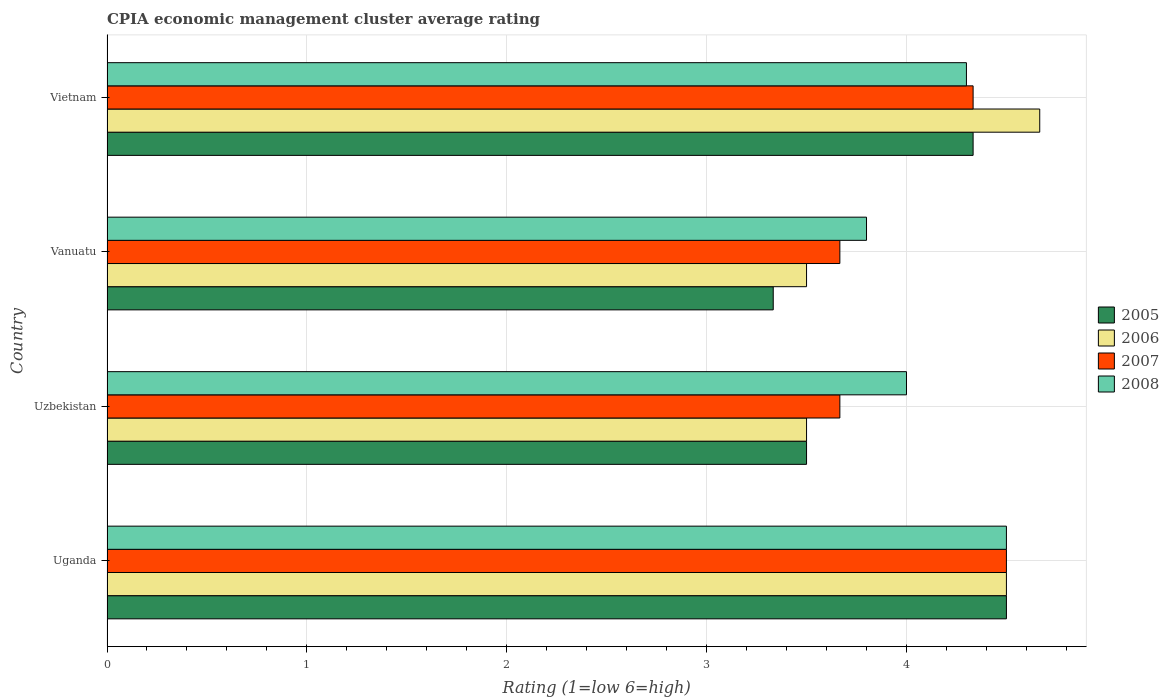How many different coloured bars are there?
Your answer should be very brief. 4. Are the number of bars on each tick of the Y-axis equal?
Provide a succinct answer. Yes. What is the label of the 3rd group of bars from the top?
Your response must be concise. Uzbekistan. Across all countries, what is the minimum CPIA rating in 2007?
Provide a short and direct response. 3.67. In which country was the CPIA rating in 2006 maximum?
Offer a very short reply. Vietnam. In which country was the CPIA rating in 2005 minimum?
Your answer should be very brief. Vanuatu. What is the total CPIA rating in 2008 in the graph?
Make the answer very short. 16.6. What is the difference between the CPIA rating in 2008 in Uzbekistan and that in Vanuatu?
Provide a short and direct response. 0.2. What is the difference between the CPIA rating in 2006 in Uzbekistan and the CPIA rating in 2008 in Vietnam?
Offer a very short reply. -0.8. What is the average CPIA rating in 2005 per country?
Offer a terse response. 3.92. What is the difference between the CPIA rating in 2008 and CPIA rating in 2006 in Uganda?
Offer a very short reply. 0. In how many countries, is the CPIA rating in 2008 greater than 3.6 ?
Provide a short and direct response. 4. What is the ratio of the CPIA rating in 2006 in Uganda to that in Vanuatu?
Offer a terse response. 1.29. Is the CPIA rating in 2007 in Uganda less than that in Uzbekistan?
Provide a succinct answer. No. What is the difference between the highest and the second highest CPIA rating in 2007?
Ensure brevity in your answer.  0.17. What is the difference between the highest and the lowest CPIA rating in 2007?
Give a very brief answer. 0.83. In how many countries, is the CPIA rating in 2006 greater than the average CPIA rating in 2006 taken over all countries?
Provide a succinct answer. 2. What does the 2nd bar from the bottom in Uzbekistan represents?
Offer a very short reply. 2006. How many bars are there?
Your answer should be compact. 16. How many countries are there in the graph?
Provide a short and direct response. 4. What is the difference between two consecutive major ticks on the X-axis?
Give a very brief answer. 1. Does the graph contain grids?
Ensure brevity in your answer.  Yes. How many legend labels are there?
Make the answer very short. 4. What is the title of the graph?
Make the answer very short. CPIA economic management cluster average rating. Does "2013" appear as one of the legend labels in the graph?
Make the answer very short. No. What is the label or title of the X-axis?
Make the answer very short. Rating (1=low 6=high). What is the Rating (1=low 6=high) in 2007 in Uzbekistan?
Provide a succinct answer. 3.67. What is the Rating (1=low 6=high) in 2005 in Vanuatu?
Provide a short and direct response. 3.33. What is the Rating (1=low 6=high) in 2006 in Vanuatu?
Your response must be concise. 3.5. What is the Rating (1=low 6=high) in 2007 in Vanuatu?
Your answer should be very brief. 3.67. What is the Rating (1=low 6=high) of 2008 in Vanuatu?
Provide a short and direct response. 3.8. What is the Rating (1=low 6=high) of 2005 in Vietnam?
Your answer should be compact. 4.33. What is the Rating (1=low 6=high) in 2006 in Vietnam?
Your answer should be very brief. 4.67. What is the Rating (1=low 6=high) of 2007 in Vietnam?
Offer a very short reply. 4.33. What is the Rating (1=low 6=high) in 2008 in Vietnam?
Offer a terse response. 4.3. Across all countries, what is the maximum Rating (1=low 6=high) of 2005?
Give a very brief answer. 4.5. Across all countries, what is the maximum Rating (1=low 6=high) in 2006?
Your response must be concise. 4.67. Across all countries, what is the maximum Rating (1=low 6=high) in 2007?
Provide a succinct answer. 4.5. Across all countries, what is the minimum Rating (1=low 6=high) of 2005?
Keep it short and to the point. 3.33. Across all countries, what is the minimum Rating (1=low 6=high) of 2006?
Offer a terse response. 3.5. Across all countries, what is the minimum Rating (1=low 6=high) of 2007?
Offer a very short reply. 3.67. What is the total Rating (1=low 6=high) of 2005 in the graph?
Make the answer very short. 15.67. What is the total Rating (1=low 6=high) in 2006 in the graph?
Provide a short and direct response. 16.17. What is the total Rating (1=low 6=high) in 2007 in the graph?
Your answer should be very brief. 16.17. What is the difference between the Rating (1=low 6=high) of 2007 in Uganda and that in Uzbekistan?
Keep it short and to the point. 0.83. What is the difference between the Rating (1=low 6=high) of 2005 in Uganda and that in Vanuatu?
Make the answer very short. 1.17. What is the difference between the Rating (1=low 6=high) in 2006 in Uganda and that in Vanuatu?
Your answer should be compact. 1. What is the difference between the Rating (1=low 6=high) of 2008 in Uganda and that in Vanuatu?
Ensure brevity in your answer.  0.7. What is the difference between the Rating (1=low 6=high) in 2005 in Uganda and that in Vietnam?
Offer a terse response. 0.17. What is the difference between the Rating (1=low 6=high) in 2006 in Uganda and that in Vietnam?
Provide a succinct answer. -0.17. What is the difference between the Rating (1=low 6=high) of 2007 in Uzbekistan and that in Vanuatu?
Your answer should be very brief. 0. What is the difference between the Rating (1=low 6=high) of 2005 in Uzbekistan and that in Vietnam?
Offer a very short reply. -0.83. What is the difference between the Rating (1=low 6=high) in 2006 in Uzbekistan and that in Vietnam?
Your answer should be very brief. -1.17. What is the difference between the Rating (1=low 6=high) in 2007 in Uzbekistan and that in Vietnam?
Offer a terse response. -0.67. What is the difference between the Rating (1=low 6=high) in 2006 in Vanuatu and that in Vietnam?
Provide a short and direct response. -1.17. What is the difference between the Rating (1=low 6=high) in 2005 in Uganda and the Rating (1=low 6=high) in 2006 in Uzbekistan?
Make the answer very short. 1. What is the difference between the Rating (1=low 6=high) of 2005 in Uganda and the Rating (1=low 6=high) of 2007 in Uzbekistan?
Make the answer very short. 0.83. What is the difference between the Rating (1=low 6=high) in 2006 in Uganda and the Rating (1=low 6=high) in 2007 in Uzbekistan?
Give a very brief answer. 0.83. What is the difference between the Rating (1=low 6=high) in 2007 in Uganda and the Rating (1=low 6=high) in 2008 in Uzbekistan?
Provide a succinct answer. 0.5. What is the difference between the Rating (1=low 6=high) of 2005 in Uganda and the Rating (1=low 6=high) of 2007 in Vanuatu?
Your answer should be compact. 0.83. What is the difference between the Rating (1=low 6=high) of 2006 in Uganda and the Rating (1=low 6=high) of 2008 in Vanuatu?
Give a very brief answer. 0.7. What is the difference between the Rating (1=low 6=high) in 2007 in Uganda and the Rating (1=low 6=high) in 2008 in Vanuatu?
Offer a terse response. 0.7. What is the difference between the Rating (1=low 6=high) of 2005 in Uganda and the Rating (1=low 6=high) of 2006 in Vietnam?
Ensure brevity in your answer.  -0.17. What is the difference between the Rating (1=low 6=high) of 2005 in Uganda and the Rating (1=low 6=high) of 2007 in Vietnam?
Your response must be concise. 0.17. What is the difference between the Rating (1=low 6=high) of 2006 in Uganda and the Rating (1=low 6=high) of 2007 in Vietnam?
Your response must be concise. 0.17. What is the difference between the Rating (1=low 6=high) of 2006 in Uganda and the Rating (1=low 6=high) of 2008 in Vietnam?
Provide a short and direct response. 0.2. What is the difference between the Rating (1=low 6=high) in 2005 in Uzbekistan and the Rating (1=low 6=high) in 2006 in Vanuatu?
Your answer should be very brief. 0. What is the difference between the Rating (1=low 6=high) in 2005 in Uzbekistan and the Rating (1=low 6=high) in 2007 in Vanuatu?
Your answer should be very brief. -0.17. What is the difference between the Rating (1=low 6=high) of 2006 in Uzbekistan and the Rating (1=low 6=high) of 2007 in Vanuatu?
Provide a succinct answer. -0.17. What is the difference between the Rating (1=low 6=high) of 2007 in Uzbekistan and the Rating (1=low 6=high) of 2008 in Vanuatu?
Your answer should be very brief. -0.13. What is the difference between the Rating (1=low 6=high) in 2005 in Uzbekistan and the Rating (1=low 6=high) in 2006 in Vietnam?
Provide a short and direct response. -1.17. What is the difference between the Rating (1=low 6=high) of 2005 in Uzbekistan and the Rating (1=low 6=high) of 2007 in Vietnam?
Provide a succinct answer. -0.83. What is the difference between the Rating (1=low 6=high) in 2005 in Uzbekistan and the Rating (1=low 6=high) in 2008 in Vietnam?
Make the answer very short. -0.8. What is the difference between the Rating (1=low 6=high) in 2006 in Uzbekistan and the Rating (1=low 6=high) in 2007 in Vietnam?
Make the answer very short. -0.83. What is the difference between the Rating (1=low 6=high) of 2006 in Uzbekistan and the Rating (1=low 6=high) of 2008 in Vietnam?
Your response must be concise. -0.8. What is the difference between the Rating (1=low 6=high) of 2007 in Uzbekistan and the Rating (1=low 6=high) of 2008 in Vietnam?
Ensure brevity in your answer.  -0.63. What is the difference between the Rating (1=low 6=high) in 2005 in Vanuatu and the Rating (1=low 6=high) in 2006 in Vietnam?
Offer a terse response. -1.33. What is the difference between the Rating (1=low 6=high) of 2005 in Vanuatu and the Rating (1=low 6=high) of 2008 in Vietnam?
Provide a succinct answer. -0.97. What is the difference between the Rating (1=low 6=high) in 2006 in Vanuatu and the Rating (1=low 6=high) in 2007 in Vietnam?
Keep it short and to the point. -0.83. What is the difference between the Rating (1=low 6=high) of 2006 in Vanuatu and the Rating (1=low 6=high) of 2008 in Vietnam?
Offer a terse response. -0.8. What is the difference between the Rating (1=low 6=high) in 2007 in Vanuatu and the Rating (1=low 6=high) in 2008 in Vietnam?
Your answer should be compact. -0.63. What is the average Rating (1=low 6=high) in 2005 per country?
Give a very brief answer. 3.92. What is the average Rating (1=low 6=high) of 2006 per country?
Your answer should be very brief. 4.04. What is the average Rating (1=low 6=high) in 2007 per country?
Your response must be concise. 4.04. What is the average Rating (1=low 6=high) in 2008 per country?
Provide a short and direct response. 4.15. What is the difference between the Rating (1=low 6=high) of 2005 and Rating (1=low 6=high) of 2006 in Uganda?
Give a very brief answer. 0. What is the difference between the Rating (1=low 6=high) of 2005 and Rating (1=low 6=high) of 2007 in Uganda?
Make the answer very short. 0. What is the difference between the Rating (1=low 6=high) in 2006 and Rating (1=low 6=high) in 2008 in Uganda?
Give a very brief answer. 0. What is the difference between the Rating (1=low 6=high) in 2007 and Rating (1=low 6=high) in 2008 in Uganda?
Keep it short and to the point. 0. What is the difference between the Rating (1=low 6=high) in 2007 and Rating (1=low 6=high) in 2008 in Uzbekistan?
Ensure brevity in your answer.  -0.33. What is the difference between the Rating (1=low 6=high) in 2005 and Rating (1=low 6=high) in 2006 in Vanuatu?
Make the answer very short. -0.17. What is the difference between the Rating (1=low 6=high) in 2005 and Rating (1=low 6=high) in 2007 in Vanuatu?
Make the answer very short. -0.33. What is the difference between the Rating (1=low 6=high) in 2005 and Rating (1=low 6=high) in 2008 in Vanuatu?
Give a very brief answer. -0.47. What is the difference between the Rating (1=low 6=high) in 2007 and Rating (1=low 6=high) in 2008 in Vanuatu?
Your answer should be very brief. -0.13. What is the difference between the Rating (1=low 6=high) in 2005 and Rating (1=low 6=high) in 2007 in Vietnam?
Make the answer very short. 0. What is the difference between the Rating (1=low 6=high) of 2005 and Rating (1=low 6=high) of 2008 in Vietnam?
Ensure brevity in your answer.  0.03. What is the difference between the Rating (1=low 6=high) in 2006 and Rating (1=low 6=high) in 2008 in Vietnam?
Your response must be concise. 0.37. What is the ratio of the Rating (1=low 6=high) of 2005 in Uganda to that in Uzbekistan?
Keep it short and to the point. 1.29. What is the ratio of the Rating (1=low 6=high) in 2006 in Uganda to that in Uzbekistan?
Provide a short and direct response. 1.29. What is the ratio of the Rating (1=low 6=high) in 2007 in Uganda to that in Uzbekistan?
Offer a very short reply. 1.23. What is the ratio of the Rating (1=low 6=high) of 2005 in Uganda to that in Vanuatu?
Offer a terse response. 1.35. What is the ratio of the Rating (1=low 6=high) of 2007 in Uganda to that in Vanuatu?
Offer a very short reply. 1.23. What is the ratio of the Rating (1=low 6=high) in 2008 in Uganda to that in Vanuatu?
Your response must be concise. 1.18. What is the ratio of the Rating (1=low 6=high) of 2005 in Uganda to that in Vietnam?
Your answer should be very brief. 1.04. What is the ratio of the Rating (1=low 6=high) of 2006 in Uganda to that in Vietnam?
Provide a succinct answer. 0.96. What is the ratio of the Rating (1=low 6=high) of 2007 in Uganda to that in Vietnam?
Make the answer very short. 1.04. What is the ratio of the Rating (1=low 6=high) in 2008 in Uganda to that in Vietnam?
Offer a very short reply. 1.05. What is the ratio of the Rating (1=low 6=high) of 2007 in Uzbekistan to that in Vanuatu?
Provide a succinct answer. 1. What is the ratio of the Rating (1=low 6=high) in 2008 in Uzbekistan to that in Vanuatu?
Provide a succinct answer. 1.05. What is the ratio of the Rating (1=low 6=high) in 2005 in Uzbekistan to that in Vietnam?
Give a very brief answer. 0.81. What is the ratio of the Rating (1=low 6=high) in 2006 in Uzbekistan to that in Vietnam?
Give a very brief answer. 0.75. What is the ratio of the Rating (1=low 6=high) of 2007 in Uzbekistan to that in Vietnam?
Ensure brevity in your answer.  0.85. What is the ratio of the Rating (1=low 6=high) in 2008 in Uzbekistan to that in Vietnam?
Your response must be concise. 0.93. What is the ratio of the Rating (1=low 6=high) in 2005 in Vanuatu to that in Vietnam?
Make the answer very short. 0.77. What is the ratio of the Rating (1=low 6=high) in 2006 in Vanuatu to that in Vietnam?
Your answer should be compact. 0.75. What is the ratio of the Rating (1=low 6=high) of 2007 in Vanuatu to that in Vietnam?
Provide a succinct answer. 0.85. What is the ratio of the Rating (1=low 6=high) in 2008 in Vanuatu to that in Vietnam?
Offer a terse response. 0.88. What is the difference between the highest and the second highest Rating (1=low 6=high) in 2005?
Give a very brief answer. 0.17. What is the difference between the highest and the second highest Rating (1=low 6=high) of 2006?
Keep it short and to the point. 0.17. What is the difference between the highest and the lowest Rating (1=low 6=high) in 2005?
Make the answer very short. 1.17. What is the difference between the highest and the lowest Rating (1=low 6=high) in 2006?
Make the answer very short. 1.17. What is the difference between the highest and the lowest Rating (1=low 6=high) of 2007?
Make the answer very short. 0.83. 